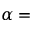Convert formula to latex. <formula><loc_0><loc_0><loc_500><loc_500>\alpha =</formula> 